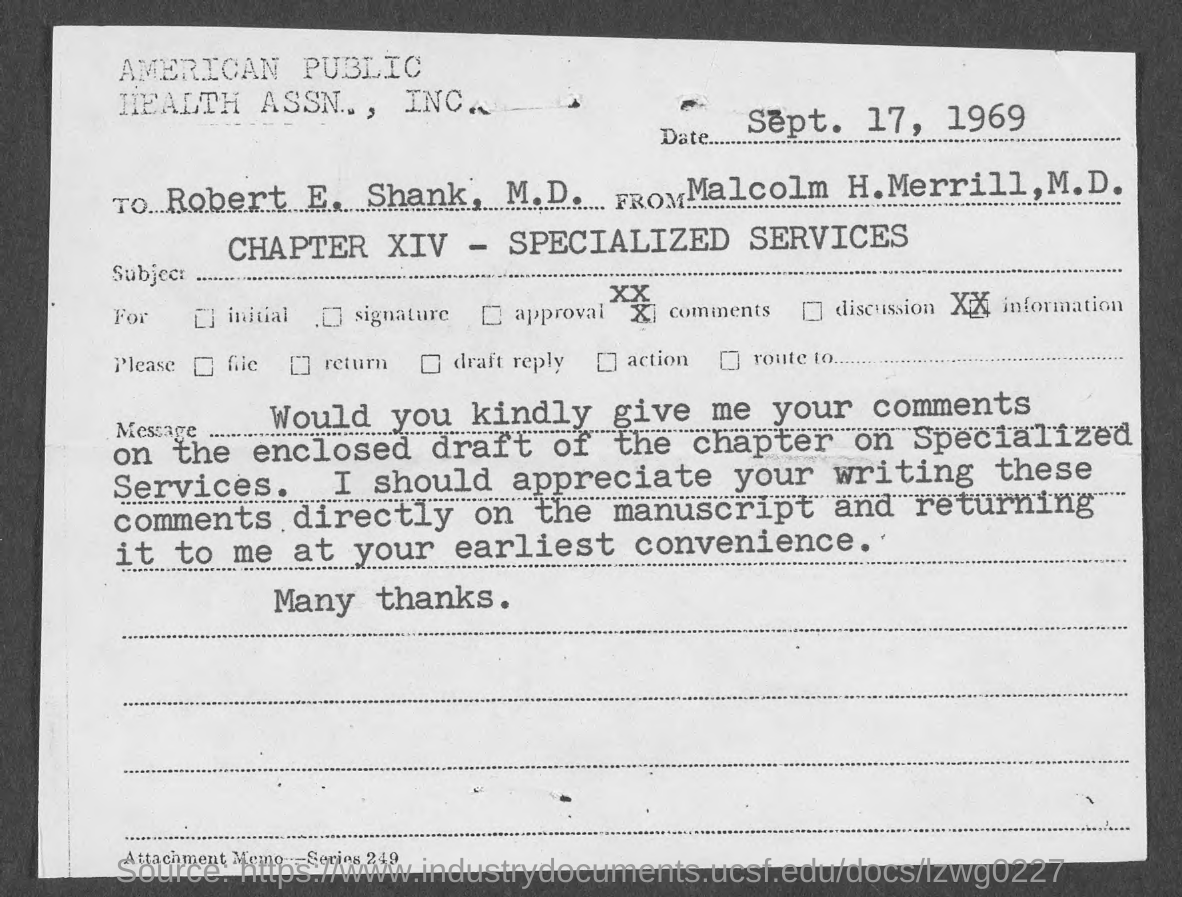Give some essential details in this illustration. The attachment memo consists of series number 249... The memorandum is dated September 17, 1969. This memo is addressed to Robert E. Shank, M.D. Chapter XIV deals with specialized services. 